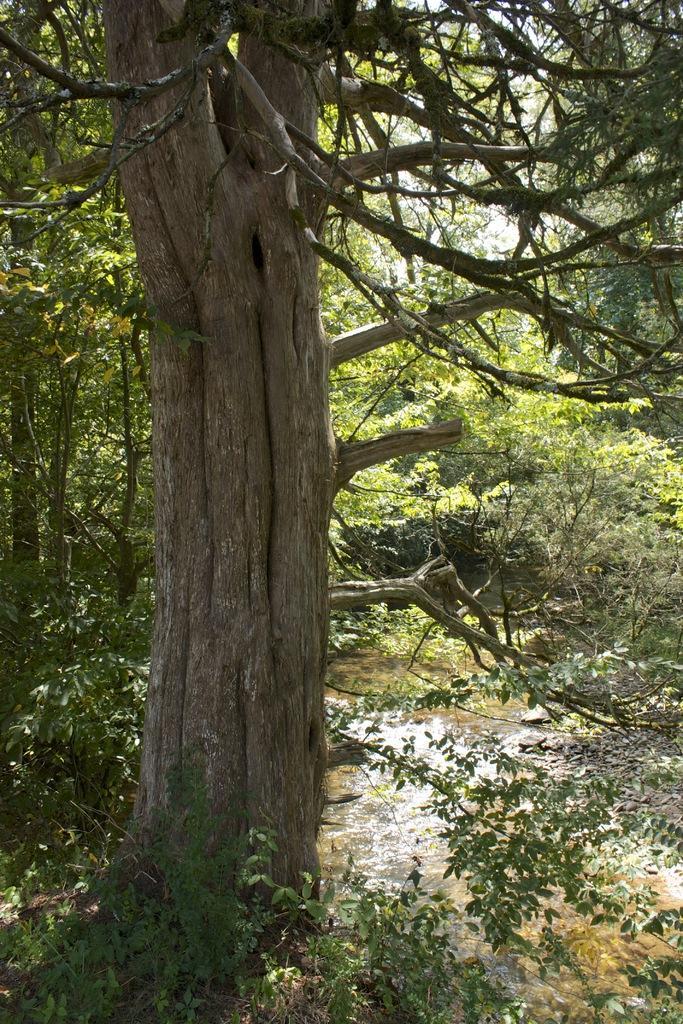How would you summarize this image in a sentence or two? On the left side of the image we can see a trees are present. At the bottom of the image water and ground are there. At the top of the image sky is present. 